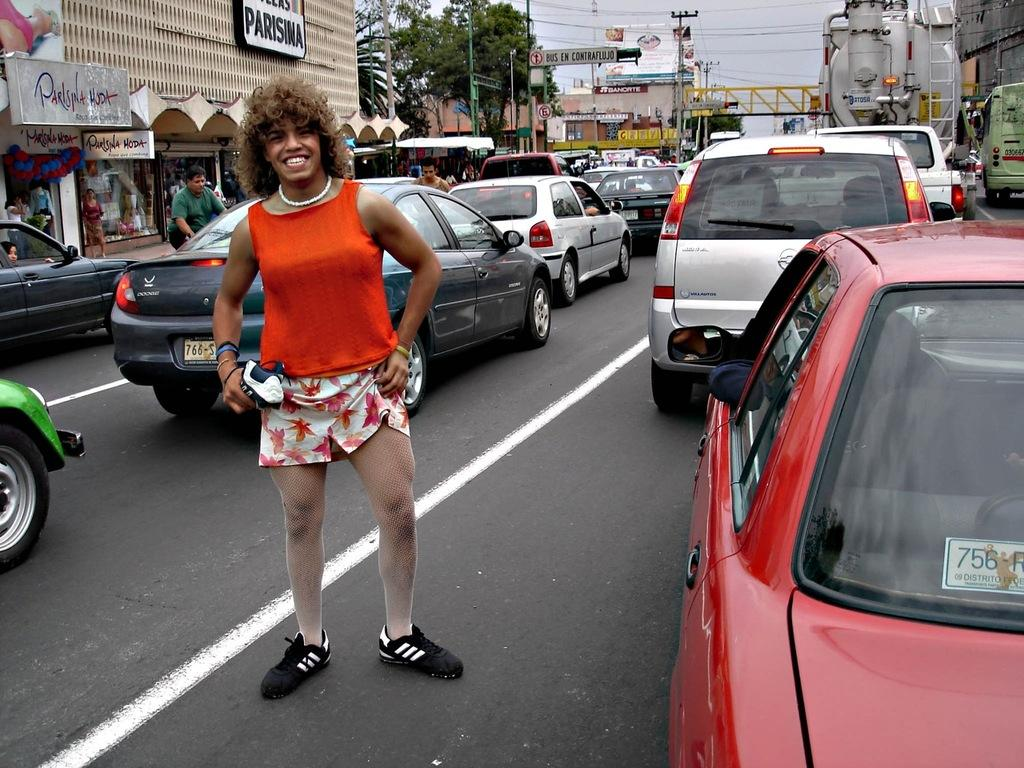What is the woman in the image doing? The woman is standing in the road. What can be seen in the background of the image? There is a car, a bridge, a building, a tree, the sky, a pole, and a light in the background. Can you describe the setting of the image? The image shows a woman standing in the road with various structures and elements in the background, including a car, a bridge, a building, a tree, the sky, a pole, and a light. What type of oatmeal is the woman eating in the image? There is no oatmeal present in the image; the woman is standing in the road. Can you describe the body language of the woman's servant in the image? There is no servant present in the image; it only shows a woman standing in the road and various elements in the background. 